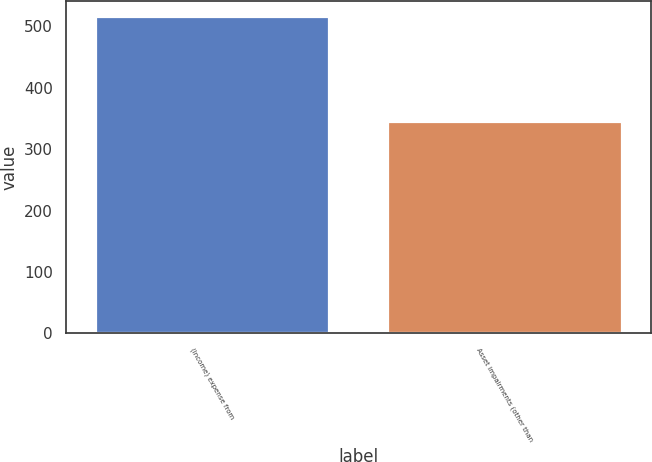Convert chart. <chart><loc_0><loc_0><loc_500><loc_500><bar_chart><fcel>(Income) expense from<fcel>Asset impairments (other than<nl><fcel>515<fcel>345<nl></chart> 